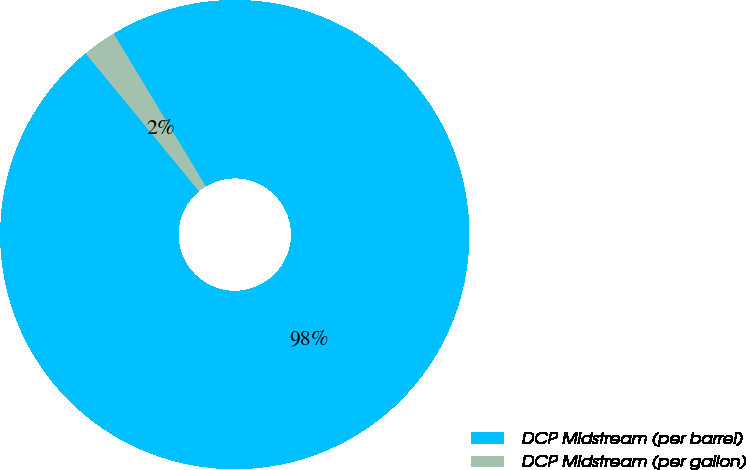Convert chart to OTSL. <chart><loc_0><loc_0><loc_500><loc_500><pie_chart><fcel>DCP Midstream (per barrel)<fcel>DCP Midstream (per gallon)<nl><fcel>97.68%<fcel>2.32%<nl></chart> 